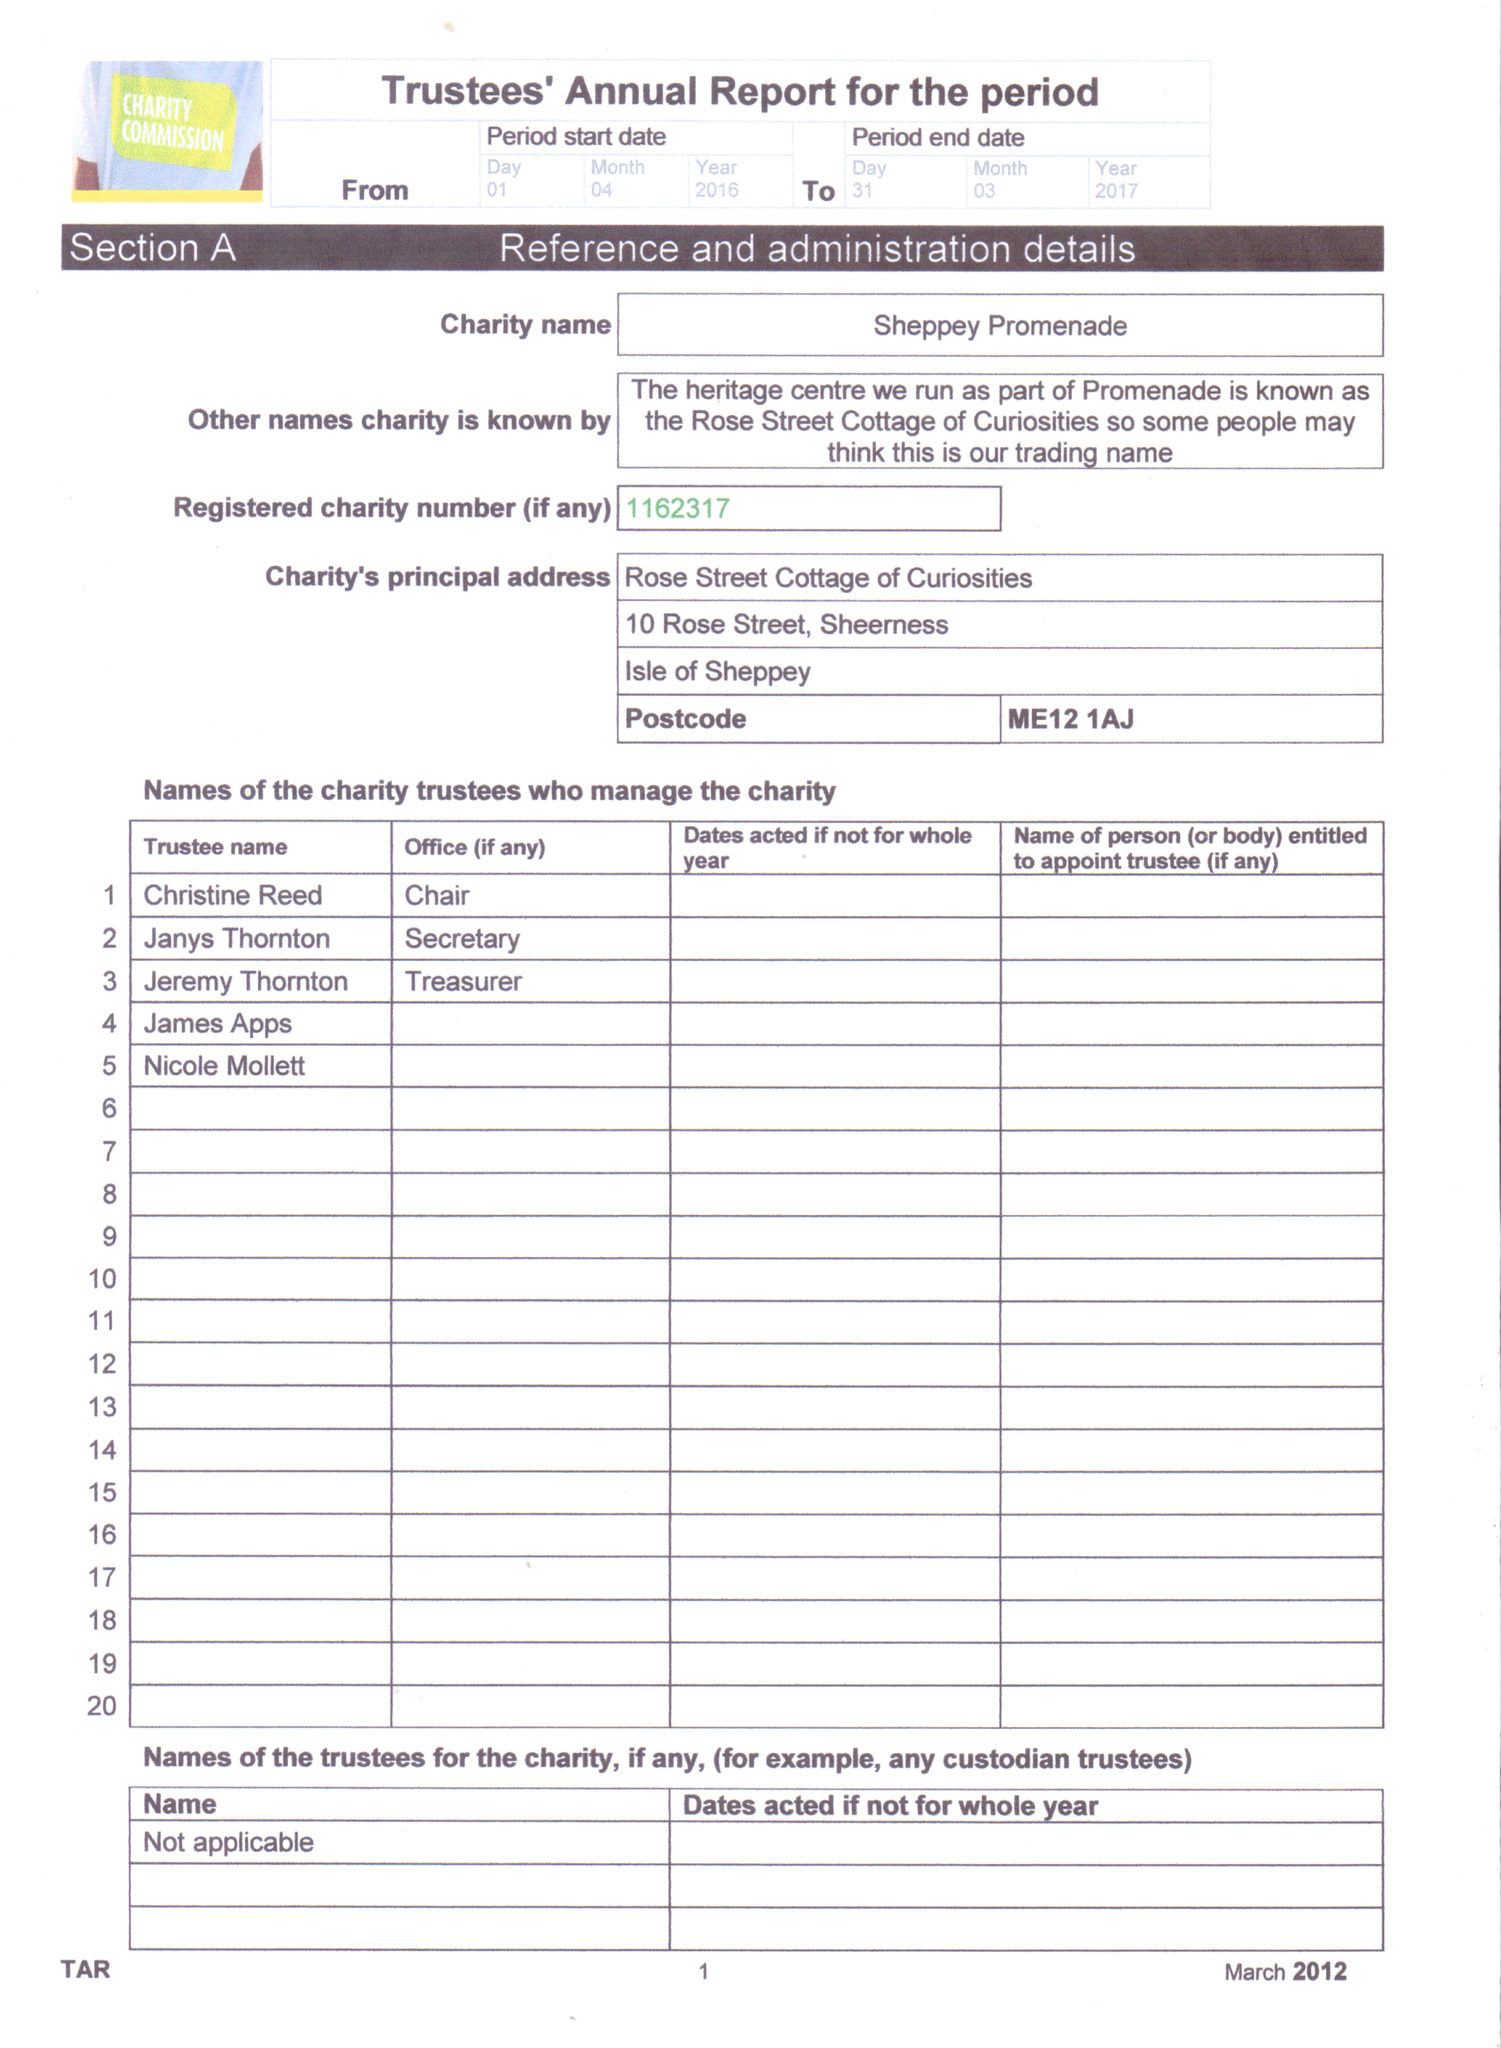What is the value for the spending_annually_in_british_pounds?
Answer the question using a single word or phrase. 9506.00 